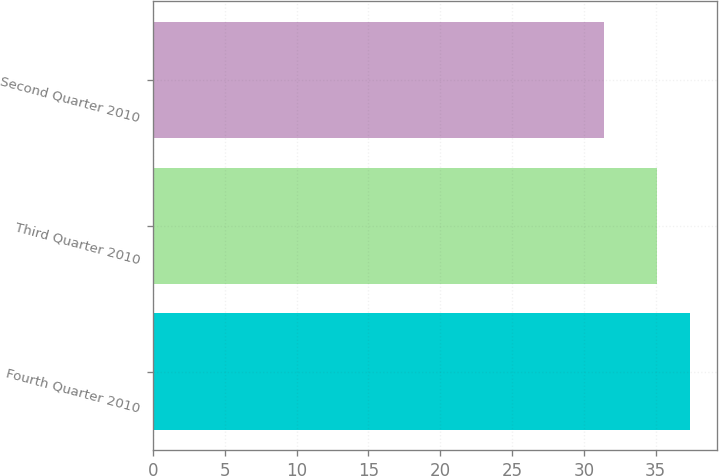<chart> <loc_0><loc_0><loc_500><loc_500><bar_chart><fcel>Fourth Quarter 2010<fcel>Third Quarter 2010<fcel>Second Quarter 2010<nl><fcel>37.4<fcel>35.1<fcel>31.4<nl></chart> 